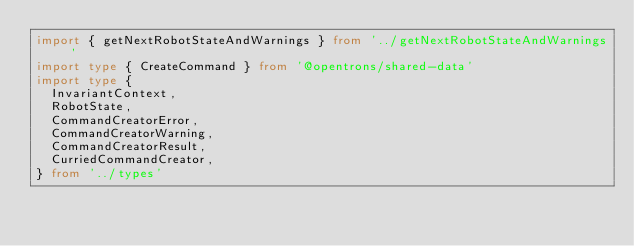<code> <loc_0><loc_0><loc_500><loc_500><_TypeScript_>import { getNextRobotStateAndWarnings } from '../getNextRobotStateAndWarnings'
import type { CreateCommand } from '@opentrons/shared-data'
import type {
  InvariantContext,
  RobotState,
  CommandCreatorError,
  CommandCreatorWarning,
  CommandCreatorResult,
  CurriedCommandCreator,
} from '../types'</code> 